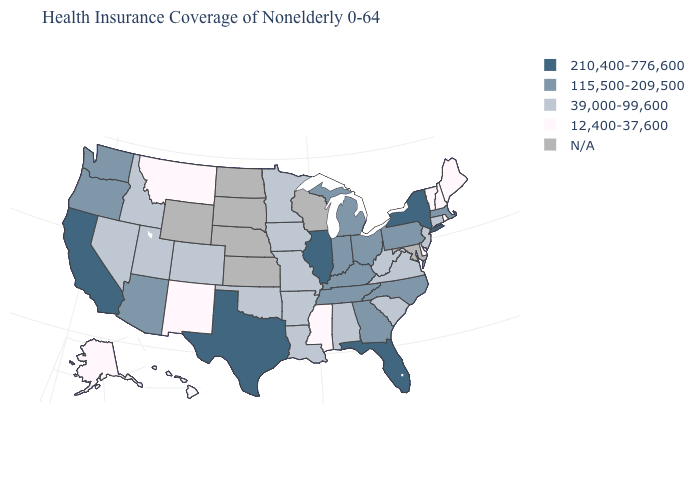What is the value of Oregon?
Concise answer only. 115,500-209,500. What is the value of Minnesota?
Quick response, please. 39,000-99,600. Among the states that border Utah , does Arizona have the highest value?
Give a very brief answer. Yes. Name the states that have a value in the range 39,000-99,600?
Write a very short answer. Alabama, Arkansas, Colorado, Connecticut, Idaho, Iowa, Louisiana, Minnesota, Missouri, Nevada, New Jersey, Oklahoma, South Carolina, Utah, Virginia, West Virginia. Which states hav the highest value in the West?
Short answer required. California. What is the highest value in the West ?
Write a very short answer. 210,400-776,600. What is the highest value in the West ?
Concise answer only. 210,400-776,600. What is the value of New Hampshire?
Answer briefly. 12,400-37,600. What is the value of Oregon?
Write a very short answer. 115,500-209,500. Which states have the highest value in the USA?
Give a very brief answer. California, Florida, Illinois, New York, Texas. What is the lowest value in states that border South Carolina?
Answer briefly. 115,500-209,500. Name the states that have a value in the range 39,000-99,600?
Write a very short answer. Alabama, Arkansas, Colorado, Connecticut, Idaho, Iowa, Louisiana, Minnesota, Missouri, Nevada, New Jersey, Oklahoma, South Carolina, Utah, Virginia, West Virginia. What is the value of Virginia?
Write a very short answer. 39,000-99,600. What is the value of Florida?
Quick response, please. 210,400-776,600. How many symbols are there in the legend?
Give a very brief answer. 5. 